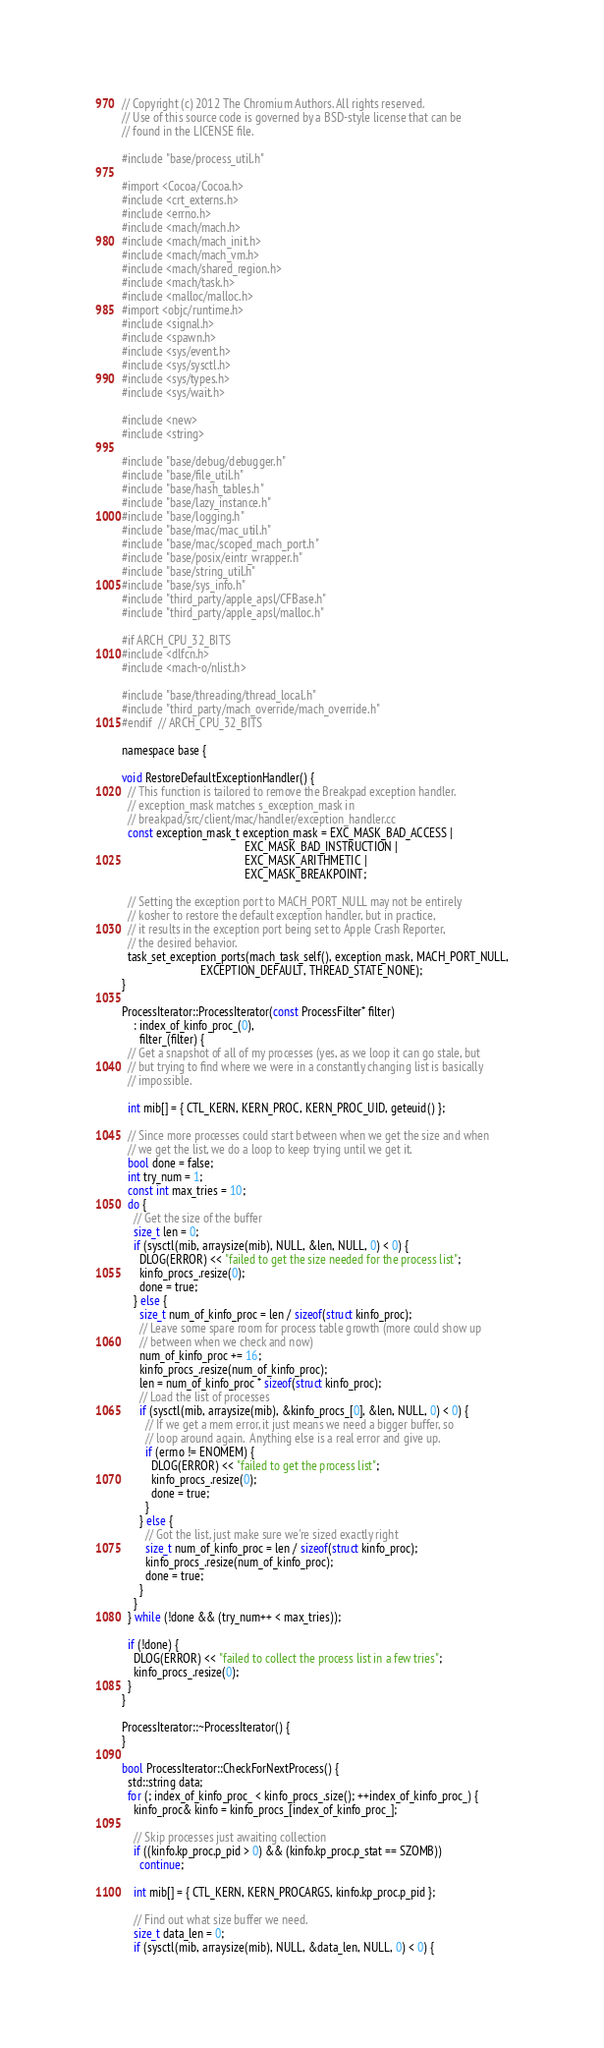<code> <loc_0><loc_0><loc_500><loc_500><_ObjectiveC_>// Copyright (c) 2012 The Chromium Authors. All rights reserved.
// Use of this source code is governed by a BSD-style license that can be
// found in the LICENSE file.

#include "base/process_util.h"

#import <Cocoa/Cocoa.h>
#include <crt_externs.h>
#include <errno.h>
#include <mach/mach.h>
#include <mach/mach_init.h>
#include <mach/mach_vm.h>
#include <mach/shared_region.h>
#include <mach/task.h>
#include <malloc/malloc.h>
#import <objc/runtime.h>
#include <signal.h>
#include <spawn.h>
#include <sys/event.h>
#include <sys/sysctl.h>
#include <sys/types.h>
#include <sys/wait.h>

#include <new>
#include <string>

#include "base/debug/debugger.h"
#include "base/file_util.h"
#include "base/hash_tables.h"
#include "base/lazy_instance.h"
#include "base/logging.h"
#include "base/mac/mac_util.h"
#include "base/mac/scoped_mach_port.h"
#include "base/posix/eintr_wrapper.h"
#include "base/string_util.h"
#include "base/sys_info.h"
#include "third_party/apple_apsl/CFBase.h"
#include "third_party/apple_apsl/malloc.h"

#if ARCH_CPU_32_BITS
#include <dlfcn.h>
#include <mach-o/nlist.h>

#include "base/threading/thread_local.h"
#include "third_party/mach_override/mach_override.h"
#endif  // ARCH_CPU_32_BITS

namespace base {

void RestoreDefaultExceptionHandler() {
  // This function is tailored to remove the Breakpad exception handler.
  // exception_mask matches s_exception_mask in
  // breakpad/src/client/mac/handler/exception_handler.cc
  const exception_mask_t exception_mask = EXC_MASK_BAD_ACCESS |
                                          EXC_MASK_BAD_INSTRUCTION |
                                          EXC_MASK_ARITHMETIC |
                                          EXC_MASK_BREAKPOINT;

  // Setting the exception port to MACH_PORT_NULL may not be entirely
  // kosher to restore the default exception handler, but in practice,
  // it results in the exception port being set to Apple Crash Reporter,
  // the desired behavior.
  task_set_exception_ports(mach_task_self(), exception_mask, MACH_PORT_NULL,
                           EXCEPTION_DEFAULT, THREAD_STATE_NONE);
}

ProcessIterator::ProcessIterator(const ProcessFilter* filter)
    : index_of_kinfo_proc_(0),
      filter_(filter) {
  // Get a snapshot of all of my processes (yes, as we loop it can go stale, but
  // but trying to find where we were in a constantly changing list is basically
  // impossible.

  int mib[] = { CTL_KERN, KERN_PROC, KERN_PROC_UID, geteuid() };

  // Since more processes could start between when we get the size and when
  // we get the list, we do a loop to keep trying until we get it.
  bool done = false;
  int try_num = 1;
  const int max_tries = 10;
  do {
    // Get the size of the buffer
    size_t len = 0;
    if (sysctl(mib, arraysize(mib), NULL, &len, NULL, 0) < 0) {
      DLOG(ERROR) << "failed to get the size needed for the process list";
      kinfo_procs_.resize(0);
      done = true;
    } else {
      size_t num_of_kinfo_proc = len / sizeof(struct kinfo_proc);
      // Leave some spare room for process table growth (more could show up
      // between when we check and now)
      num_of_kinfo_proc += 16;
      kinfo_procs_.resize(num_of_kinfo_proc);
      len = num_of_kinfo_proc * sizeof(struct kinfo_proc);
      // Load the list of processes
      if (sysctl(mib, arraysize(mib), &kinfo_procs_[0], &len, NULL, 0) < 0) {
        // If we get a mem error, it just means we need a bigger buffer, so
        // loop around again.  Anything else is a real error and give up.
        if (errno != ENOMEM) {
          DLOG(ERROR) << "failed to get the process list";
          kinfo_procs_.resize(0);
          done = true;
        }
      } else {
        // Got the list, just make sure we're sized exactly right
        size_t num_of_kinfo_proc = len / sizeof(struct kinfo_proc);
        kinfo_procs_.resize(num_of_kinfo_proc);
        done = true;
      }
    }
  } while (!done && (try_num++ < max_tries));

  if (!done) {
    DLOG(ERROR) << "failed to collect the process list in a few tries";
    kinfo_procs_.resize(0);
  }
}

ProcessIterator::~ProcessIterator() {
}

bool ProcessIterator::CheckForNextProcess() {
  std::string data;
  for (; index_of_kinfo_proc_ < kinfo_procs_.size(); ++index_of_kinfo_proc_) {
    kinfo_proc& kinfo = kinfo_procs_[index_of_kinfo_proc_];

    // Skip processes just awaiting collection
    if ((kinfo.kp_proc.p_pid > 0) && (kinfo.kp_proc.p_stat == SZOMB))
      continue;

    int mib[] = { CTL_KERN, KERN_PROCARGS, kinfo.kp_proc.p_pid };

    // Find out what size buffer we need.
    size_t data_len = 0;
    if (sysctl(mib, arraysize(mib), NULL, &data_len, NULL, 0) < 0) {</code> 